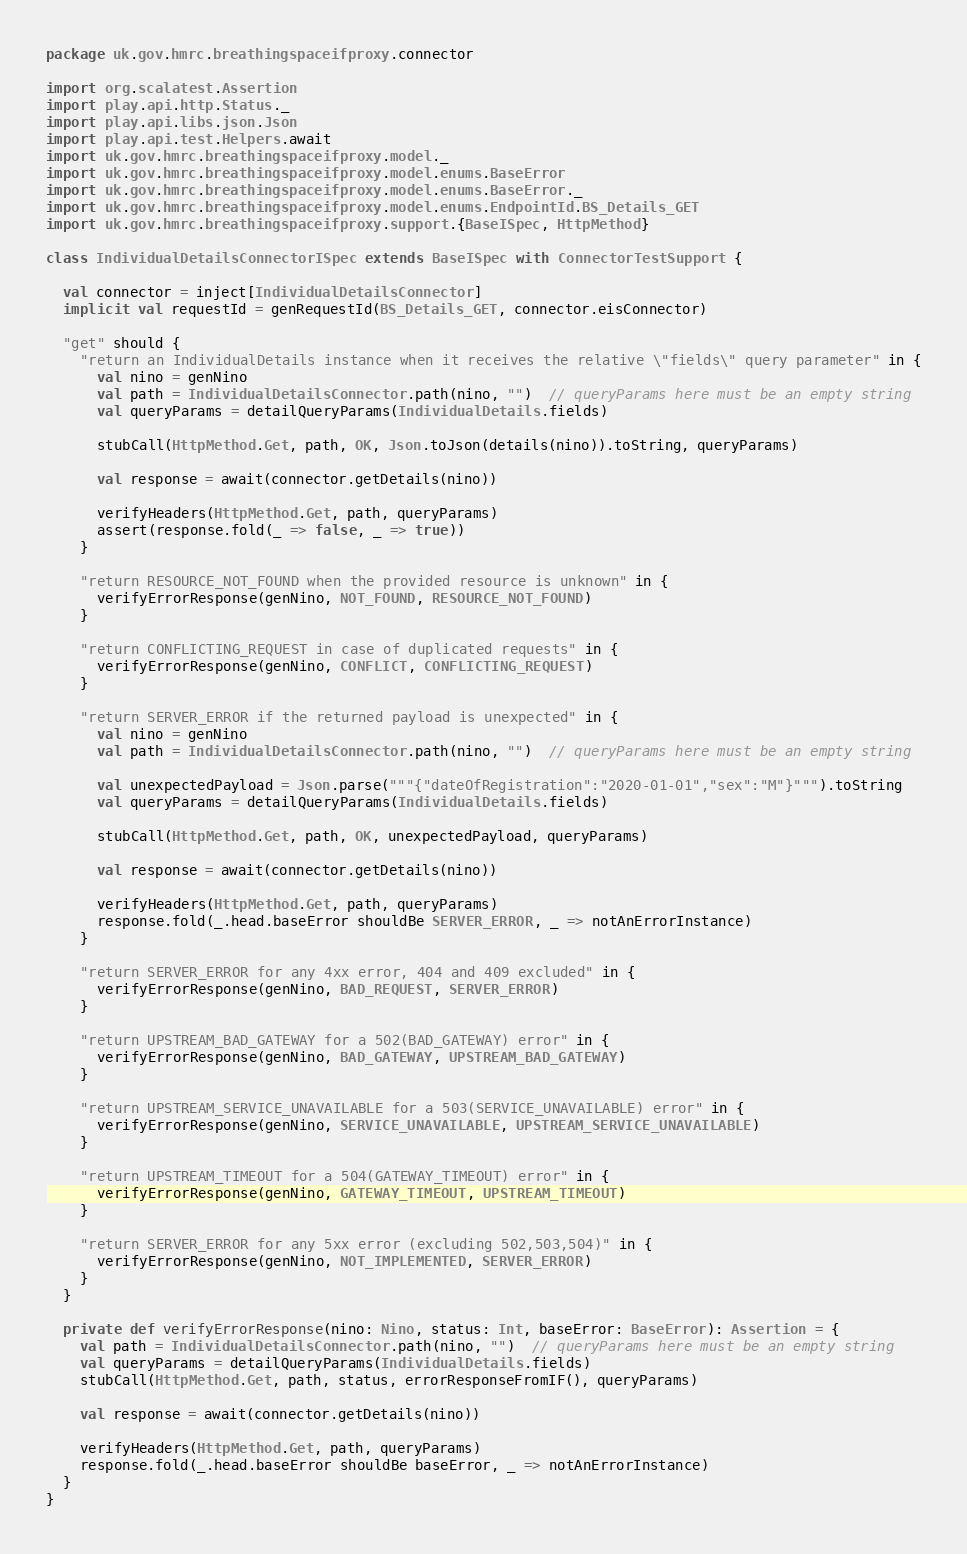<code> <loc_0><loc_0><loc_500><loc_500><_Scala_>package uk.gov.hmrc.breathingspaceifproxy.connector

import org.scalatest.Assertion
import play.api.http.Status._
import play.api.libs.json.Json
import play.api.test.Helpers.await
import uk.gov.hmrc.breathingspaceifproxy.model._
import uk.gov.hmrc.breathingspaceifproxy.model.enums.BaseError
import uk.gov.hmrc.breathingspaceifproxy.model.enums.BaseError._
import uk.gov.hmrc.breathingspaceifproxy.model.enums.EndpointId.BS_Details_GET
import uk.gov.hmrc.breathingspaceifproxy.support.{BaseISpec, HttpMethod}

class IndividualDetailsConnectorISpec extends BaseISpec with ConnectorTestSupport {

  val connector = inject[IndividualDetailsConnector]
  implicit val requestId = genRequestId(BS_Details_GET, connector.eisConnector)

  "get" should {
    "return an IndividualDetails instance when it receives the relative \"fields\" query parameter" in {
      val nino = genNino
      val path = IndividualDetailsConnector.path(nino, "")  // queryParams here must be an empty string
      val queryParams = detailQueryParams(IndividualDetails.fields)

      stubCall(HttpMethod.Get, path, OK, Json.toJson(details(nino)).toString, queryParams)

      val response = await(connector.getDetails(nino))

      verifyHeaders(HttpMethod.Get, path, queryParams)
      assert(response.fold(_ => false, _ => true))
    }

    "return RESOURCE_NOT_FOUND when the provided resource is unknown" in {
      verifyErrorResponse(genNino, NOT_FOUND, RESOURCE_NOT_FOUND)
    }

    "return CONFLICTING_REQUEST in case of duplicated requests" in {
      verifyErrorResponse(genNino, CONFLICT, CONFLICTING_REQUEST)
    }

    "return SERVER_ERROR if the returned payload is unexpected" in {
      val nino = genNino
      val path = IndividualDetailsConnector.path(nino, "")  // queryParams here must be an empty string

      val unexpectedPayload = Json.parse("""{"dateOfRegistration":"2020-01-01","sex":"M"}""").toString
      val queryParams = detailQueryParams(IndividualDetails.fields)

      stubCall(HttpMethod.Get, path, OK, unexpectedPayload, queryParams)

      val response = await(connector.getDetails(nino))

      verifyHeaders(HttpMethod.Get, path, queryParams)
      response.fold(_.head.baseError shouldBe SERVER_ERROR, _ => notAnErrorInstance)
    }

    "return SERVER_ERROR for any 4xx error, 404 and 409 excluded" in {
      verifyErrorResponse(genNino, BAD_REQUEST, SERVER_ERROR)
    }

    "return UPSTREAM_BAD_GATEWAY for a 502(BAD_GATEWAY) error" in {
      verifyErrorResponse(genNino, BAD_GATEWAY, UPSTREAM_BAD_GATEWAY)
    }

    "return UPSTREAM_SERVICE_UNAVAILABLE for a 503(SERVICE_UNAVAILABLE) error" in {
      verifyErrorResponse(genNino, SERVICE_UNAVAILABLE, UPSTREAM_SERVICE_UNAVAILABLE)
    }

    "return UPSTREAM_TIMEOUT for a 504(GATEWAY_TIMEOUT) error" in {
      verifyErrorResponse(genNino, GATEWAY_TIMEOUT, UPSTREAM_TIMEOUT)
    }

    "return SERVER_ERROR for any 5xx error (excluding 502,503,504)" in {
      verifyErrorResponse(genNino, NOT_IMPLEMENTED, SERVER_ERROR)
    }
  }

  private def verifyErrorResponse(nino: Nino, status: Int, baseError: BaseError): Assertion = {
    val path = IndividualDetailsConnector.path(nino, "")  // queryParams here must be an empty string
    val queryParams = detailQueryParams(IndividualDetails.fields)
    stubCall(HttpMethod.Get, path, status, errorResponseFromIF(), queryParams)

    val response = await(connector.getDetails(nino))

    verifyHeaders(HttpMethod.Get, path, queryParams)
    response.fold(_.head.baseError shouldBe baseError, _ => notAnErrorInstance)
  }
}
</code> 